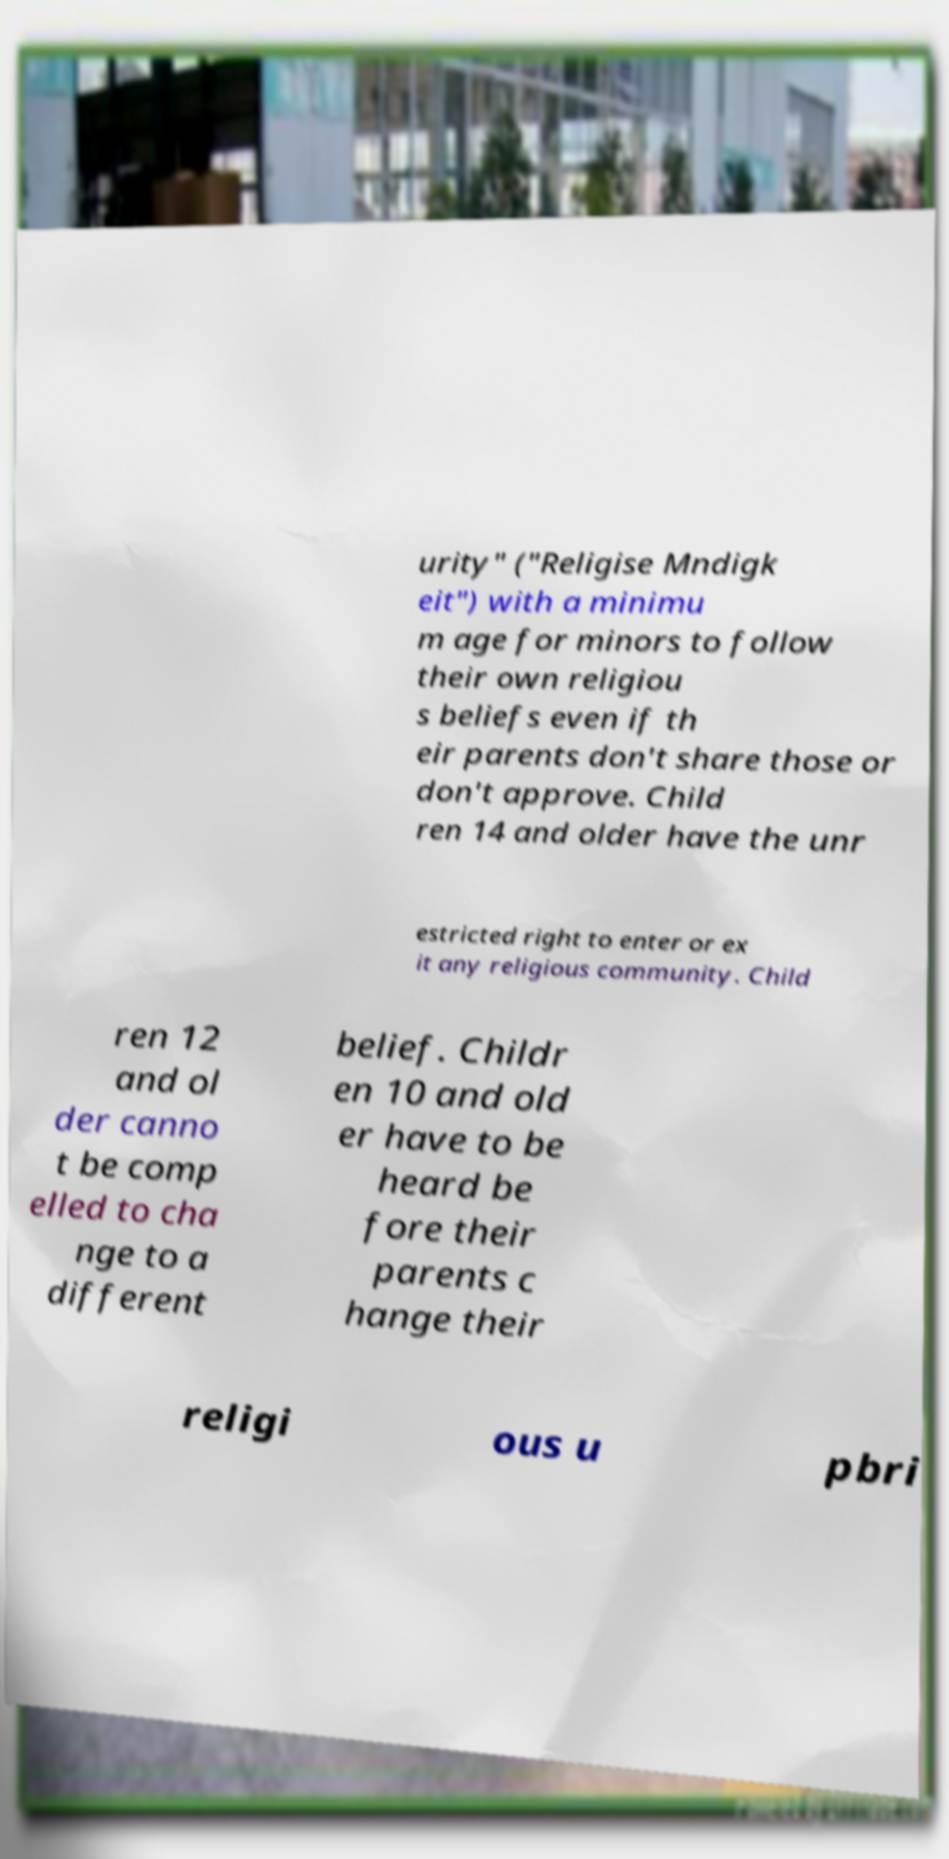For documentation purposes, I need the text within this image transcribed. Could you provide that? urity" ("Religise Mndigk eit") with a minimu m age for minors to follow their own religiou s beliefs even if th eir parents don't share those or don't approve. Child ren 14 and older have the unr estricted right to enter or ex it any religious community. Child ren 12 and ol der canno t be comp elled to cha nge to a different belief. Childr en 10 and old er have to be heard be fore their parents c hange their religi ous u pbri 